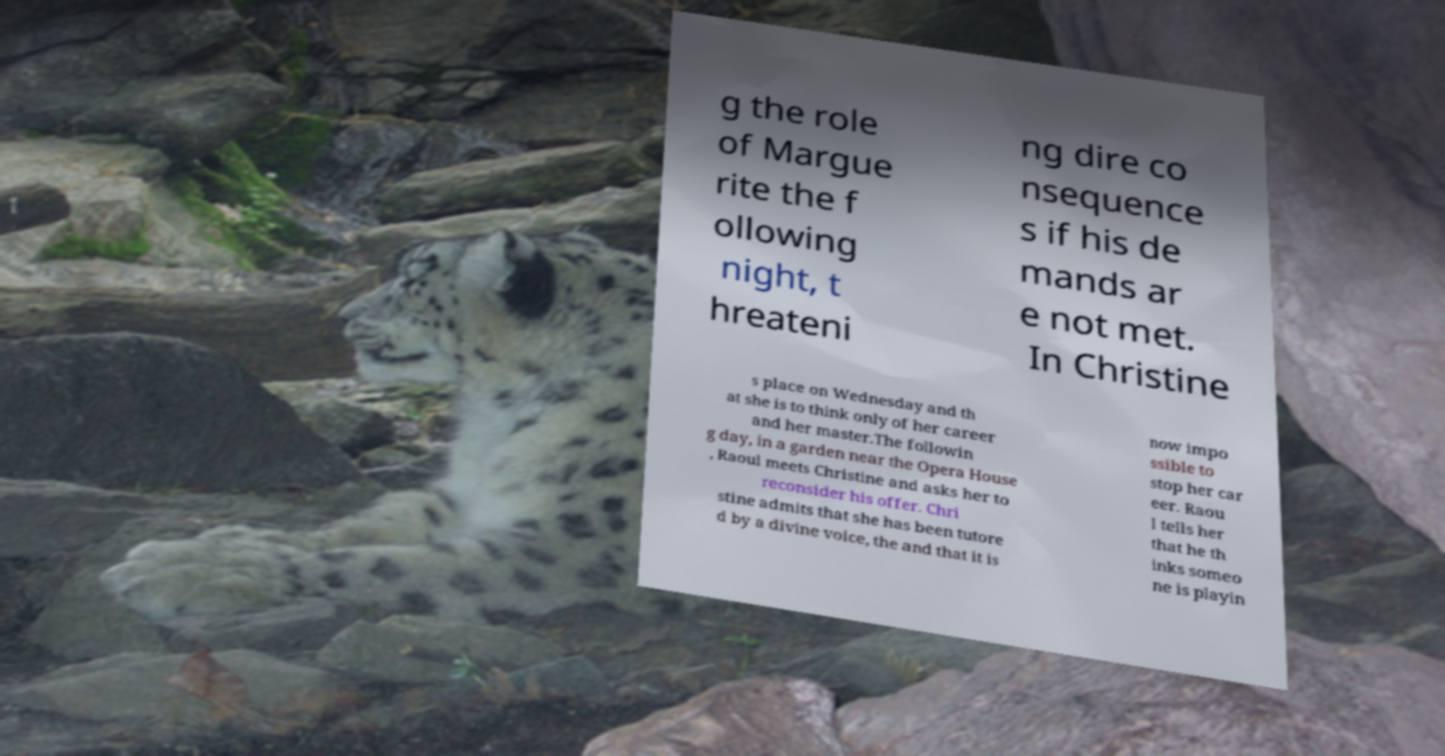Could you extract and type out the text from this image? g the role of Margue rite the f ollowing night, t hreateni ng dire co nsequence s if his de mands ar e not met. In Christine s place on Wednesday and th at she is to think only of her career and her master.The followin g day, in a garden near the Opera House , Raoul meets Christine and asks her to reconsider his offer. Chri stine admits that she has been tutore d by a divine voice, the and that it is now impo ssible to stop her car eer. Raou l tells her that he th inks someo ne is playin 